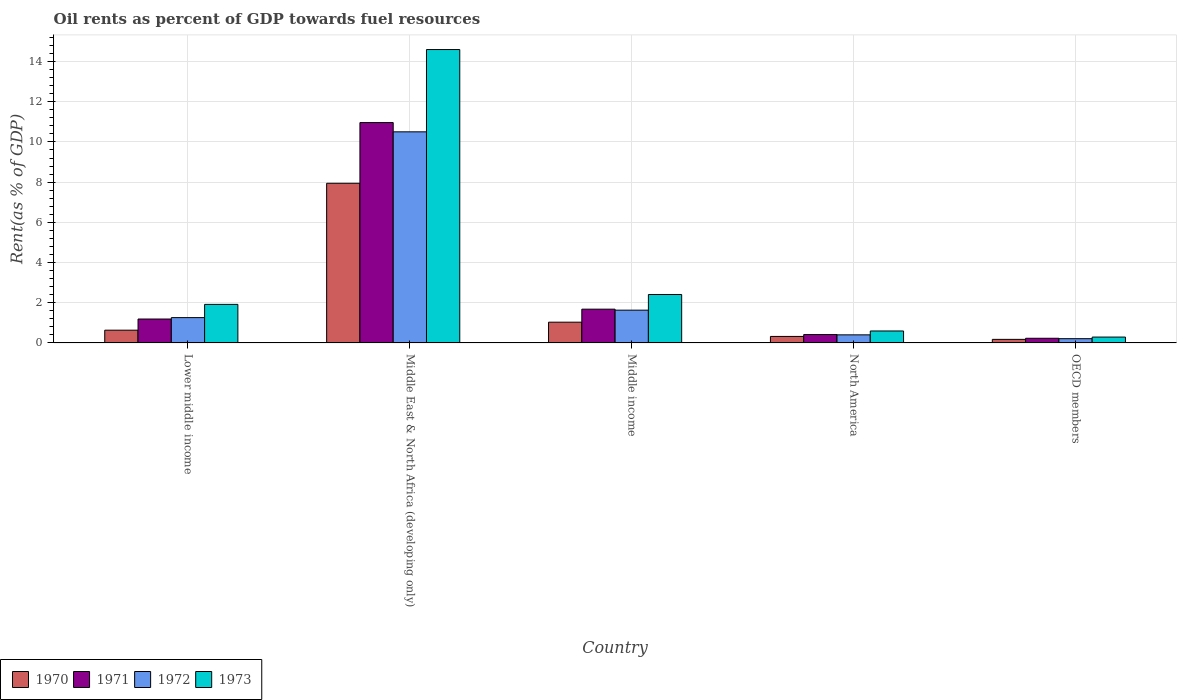Are the number of bars per tick equal to the number of legend labels?
Keep it short and to the point. Yes. What is the oil rent in 1973 in Middle income?
Your response must be concise. 2.41. Across all countries, what is the maximum oil rent in 1970?
Provide a short and direct response. 7.94. Across all countries, what is the minimum oil rent in 1970?
Give a very brief answer. 0.18. In which country was the oil rent in 1972 maximum?
Provide a short and direct response. Middle East & North Africa (developing only). What is the total oil rent in 1970 in the graph?
Ensure brevity in your answer.  10.11. What is the difference between the oil rent in 1971 in Middle East & North Africa (developing only) and that in North America?
Your answer should be very brief. 10.55. What is the difference between the oil rent in 1972 in Middle East & North Africa (developing only) and the oil rent in 1973 in Lower middle income?
Make the answer very short. 8.58. What is the average oil rent in 1972 per country?
Provide a short and direct response. 2.8. What is the difference between the oil rent of/in 1972 and oil rent of/in 1971 in Middle income?
Provide a short and direct response. -0.05. What is the ratio of the oil rent in 1971 in Middle income to that in North America?
Your response must be concise. 4.03. Is the difference between the oil rent in 1972 in Lower middle income and Middle East & North Africa (developing only) greater than the difference between the oil rent in 1971 in Lower middle income and Middle East & North Africa (developing only)?
Your answer should be compact. Yes. What is the difference between the highest and the second highest oil rent in 1973?
Keep it short and to the point. -0.49. What is the difference between the highest and the lowest oil rent in 1973?
Provide a succinct answer. 14.3. In how many countries, is the oil rent in 1972 greater than the average oil rent in 1972 taken over all countries?
Make the answer very short. 1. Is the sum of the oil rent in 1971 in Middle East & North Africa (developing only) and OECD members greater than the maximum oil rent in 1972 across all countries?
Your answer should be compact. Yes. Is it the case that in every country, the sum of the oil rent in 1971 and oil rent in 1973 is greater than the sum of oil rent in 1970 and oil rent in 1972?
Keep it short and to the point. No. What does the 4th bar from the left in OECD members represents?
Offer a very short reply. 1973. Is it the case that in every country, the sum of the oil rent in 1972 and oil rent in 1970 is greater than the oil rent in 1973?
Keep it short and to the point. No. Are the values on the major ticks of Y-axis written in scientific E-notation?
Provide a succinct answer. No. Does the graph contain any zero values?
Your answer should be very brief. No. How many legend labels are there?
Provide a short and direct response. 4. How are the legend labels stacked?
Offer a very short reply. Horizontal. What is the title of the graph?
Provide a short and direct response. Oil rents as percent of GDP towards fuel resources. Does "1991" appear as one of the legend labels in the graph?
Provide a succinct answer. No. What is the label or title of the Y-axis?
Ensure brevity in your answer.  Rent(as % of GDP). What is the Rent(as % of GDP) in 1970 in Lower middle income?
Provide a succinct answer. 0.63. What is the Rent(as % of GDP) of 1971 in Lower middle income?
Offer a terse response. 1.19. What is the Rent(as % of GDP) of 1972 in Lower middle income?
Your response must be concise. 1.26. What is the Rent(as % of GDP) of 1973 in Lower middle income?
Provide a short and direct response. 1.92. What is the Rent(as % of GDP) in 1970 in Middle East & North Africa (developing only)?
Keep it short and to the point. 7.94. What is the Rent(as % of GDP) in 1971 in Middle East & North Africa (developing only)?
Provide a short and direct response. 10.96. What is the Rent(as % of GDP) of 1972 in Middle East & North Africa (developing only)?
Your response must be concise. 10.5. What is the Rent(as % of GDP) of 1973 in Middle East & North Africa (developing only)?
Make the answer very short. 14.6. What is the Rent(as % of GDP) in 1970 in Middle income?
Provide a short and direct response. 1.03. What is the Rent(as % of GDP) in 1971 in Middle income?
Provide a succinct answer. 1.68. What is the Rent(as % of GDP) of 1972 in Middle income?
Provide a succinct answer. 1.63. What is the Rent(as % of GDP) in 1973 in Middle income?
Make the answer very short. 2.41. What is the Rent(as % of GDP) of 1970 in North America?
Offer a terse response. 0.32. What is the Rent(as % of GDP) in 1971 in North America?
Your answer should be compact. 0.42. What is the Rent(as % of GDP) in 1972 in North America?
Ensure brevity in your answer.  0.4. What is the Rent(as % of GDP) in 1973 in North America?
Your response must be concise. 0.6. What is the Rent(as % of GDP) in 1970 in OECD members?
Your answer should be compact. 0.18. What is the Rent(as % of GDP) of 1971 in OECD members?
Make the answer very short. 0.23. What is the Rent(as % of GDP) of 1972 in OECD members?
Keep it short and to the point. 0.21. What is the Rent(as % of GDP) of 1973 in OECD members?
Keep it short and to the point. 0.29. Across all countries, what is the maximum Rent(as % of GDP) in 1970?
Provide a short and direct response. 7.94. Across all countries, what is the maximum Rent(as % of GDP) of 1971?
Your response must be concise. 10.96. Across all countries, what is the maximum Rent(as % of GDP) in 1972?
Your response must be concise. 10.5. Across all countries, what is the maximum Rent(as % of GDP) in 1973?
Your answer should be compact. 14.6. Across all countries, what is the minimum Rent(as % of GDP) of 1970?
Provide a succinct answer. 0.18. Across all countries, what is the minimum Rent(as % of GDP) of 1971?
Your answer should be very brief. 0.23. Across all countries, what is the minimum Rent(as % of GDP) of 1972?
Offer a very short reply. 0.21. Across all countries, what is the minimum Rent(as % of GDP) of 1973?
Offer a terse response. 0.29. What is the total Rent(as % of GDP) in 1970 in the graph?
Your answer should be compact. 10.11. What is the total Rent(as % of GDP) in 1971 in the graph?
Provide a short and direct response. 14.48. What is the total Rent(as % of GDP) of 1972 in the graph?
Offer a terse response. 14.01. What is the total Rent(as % of GDP) in 1973 in the graph?
Your answer should be very brief. 19.81. What is the difference between the Rent(as % of GDP) of 1970 in Lower middle income and that in Middle East & North Africa (developing only)?
Your answer should be compact. -7.31. What is the difference between the Rent(as % of GDP) of 1971 in Lower middle income and that in Middle East & North Africa (developing only)?
Make the answer very short. -9.77. What is the difference between the Rent(as % of GDP) in 1972 in Lower middle income and that in Middle East & North Africa (developing only)?
Provide a short and direct response. -9.24. What is the difference between the Rent(as % of GDP) of 1973 in Lower middle income and that in Middle East & North Africa (developing only)?
Offer a very short reply. -12.68. What is the difference between the Rent(as % of GDP) in 1970 in Lower middle income and that in Middle income?
Keep it short and to the point. -0.4. What is the difference between the Rent(as % of GDP) of 1971 in Lower middle income and that in Middle income?
Provide a succinct answer. -0.49. What is the difference between the Rent(as % of GDP) of 1972 in Lower middle income and that in Middle income?
Your answer should be compact. -0.37. What is the difference between the Rent(as % of GDP) of 1973 in Lower middle income and that in Middle income?
Keep it short and to the point. -0.49. What is the difference between the Rent(as % of GDP) in 1970 in Lower middle income and that in North America?
Your answer should be compact. 0.31. What is the difference between the Rent(as % of GDP) in 1971 in Lower middle income and that in North America?
Offer a terse response. 0.77. What is the difference between the Rent(as % of GDP) of 1972 in Lower middle income and that in North America?
Keep it short and to the point. 0.86. What is the difference between the Rent(as % of GDP) in 1973 in Lower middle income and that in North America?
Make the answer very short. 1.32. What is the difference between the Rent(as % of GDP) in 1970 in Lower middle income and that in OECD members?
Your answer should be compact. 0.46. What is the difference between the Rent(as % of GDP) of 1971 in Lower middle income and that in OECD members?
Your answer should be compact. 0.96. What is the difference between the Rent(as % of GDP) in 1972 in Lower middle income and that in OECD members?
Your answer should be very brief. 1.05. What is the difference between the Rent(as % of GDP) of 1973 in Lower middle income and that in OECD members?
Your answer should be compact. 1.63. What is the difference between the Rent(as % of GDP) of 1970 in Middle East & North Africa (developing only) and that in Middle income?
Ensure brevity in your answer.  6.91. What is the difference between the Rent(as % of GDP) in 1971 in Middle East & North Africa (developing only) and that in Middle income?
Your answer should be very brief. 9.28. What is the difference between the Rent(as % of GDP) of 1972 in Middle East & North Africa (developing only) and that in Middle income?
Offer a very short reply. 8.87. What is the difference between the Rent(as % of GDP) in 1973 in Middle East & North Africa (developing only) and that in Middle income?
Provide a succinct answer. 12.19. What is the difference between the Rent(as % of GDP) of 1970 in Middle East & North Africa (developing only) and that in North America?
Ensure brevity in your answer.  7.62. What is the difference between the Rent(as % of GDP) in 1971 in Middle East & North Africa (developing only) and that in North America?
Keep it short and to the point. 10.55. What is the difference between the Rent(as % of GDP) of 1972 in Middle East & North Africa (developing only) and that in North America?
Offer a terse response. 10.1. What is the difference between the Rent(as % of GDP) of 1973 in Middle East & North Africa (developing only) and that in North America?
Give a very brief answer. 14. What is the difference between the Rent(as % of GDP) in 1970 in Middle East & North Africa (developing only) and that in OECD members?
Keep it short and to the point. 7.77. What is the difference between the Rent(as % of GDP) of 1971 in Middle East & North Africa (developing only) and that in OECD members?
Offer a terse response. 10.73. What is the difference between the Rent(as % of GDP) of 1972 in Middle East & North Africa (developing only) and that in OECD members?
Make the answer very short. 10.29. What is the difference between the Rent(as % of GDP) of 1973 in Middle East & North Africa (developing only) and that in OECD members?
Your answer should be compact. 14.3. What is the difference between the Rent(as % of GDP) in 1970 in Middle income and that in North America?
Give a very brief answer. 0.71. What is the difference between the Rent(as % of GDP) of 1971 in Middle income and that in North America?
Offer a terse response. 1.26. What is the difference between the Rent(as % of GDP) of 1972 in Middle income and that in North America?
Provide a succinct answer. 1.23. What is the difference between the Rent(as % of GDP) of 1973 in Middle income and that in North America?
Your answer should be compact. 1.81. What is the difference between the Rent(as % of GDP) in 1970 in Middle income and that in OECD members?
Your answer should be compact. 0.85. What is the difference between the Rent(as % of GDP) in 1971 in Middle income and that in OECD members?
Keep it short and to the point. 1.45. What is the difference between the Rent(as % of GDP) of 1972 in Middle income and that in OECD members?
Your answer should be compact. 1.42. What is the difference between the Rent(as % of GDP) of 1973 in Middle income and that in OECD members?
Ensure brevity in your answer.  2.12. What is the difference between the Rent(as % of GDP) in 1970 in North America and that in OECD members?
Ensure brevity in your answer.  0.15. What is the difference between the Rent(as % of GDP) in 1971 in North America and that in OECD members?
Ensure brevity in your answer.  0.18. What is the difference between the Rent(as % of GDP) of 1972 in North America and that in OECD members?
Your response must be concise. 0.19. What is the difference between the Rent(as % of GDP) of 1973 in North America and that in OECD members?
Your response must be concise. 0.3. What is the difference between the Rent(as % of GDP) in 1970 in Lower middle income and the Rent(as % of GDP) in 1971 in Middle East & North Africa (developing only)?
Ensure brevity in your answer.  -10.33. What is the difference between the Rent(as % of GDP) of 1970 in Lower middle income and the Rent(as % of GDP) of 1972 in Middle East & North Africa (developing only)?
Make the answer very short. -9.87. What is the difference between the Rent(as % of GDP) in 1970 in Lower middle income and the Rent(as % of GDP) in 1973 in Middle East & North Africa (developing only)?
Your answer should be compact. -13.96. What is the difference between the Rent(as % of GDP) of 1971 in Lower middle income and the Rent(as % of GDP) of 1972 in Middle East & North Africa (developing only)?
Offer a terse response. -9.31. What is the difference between the Rent(as % of GDP) in 1971 in Lower middle income and the Rent(as % of GDP) in 1973 in Middle East & North Africa (developing only)?
Offer a very short reply. -13.41. What is the difference between the Rent(as % of GDP) in 1972 in Lower middle income and the Rent(as % of GDP) in 1973 in Middle East & North Africa (developing only)?
Keep it short and to the point. -13.34. What is the difference between the Rent(as % of GDP) in 1970 in Lower middle income and the Rent(as % of GDP) in 1971 in Middle income?
Your answer should be very brief. -1.05. What is the difference between the Rent(as % of GDP) of 1970 in Lower middle income and the Rent(as % of GDP) of 1972 in Middle income?
Offer a terse response. -1. What is the difference between the Rent(as % of GDP) in 1970 in Lower middle income and the Rent(as % of GDP) in 1973 in Middle income?
Provide a short and direct response. -1.77. What is the difference between the Rent(as % of GDP) of 1971 in Lower middle income and the Rent(as % of GDP) of 1972 in Middle income?
Your answer should be compact. -0.44. What is the difference between the Rent(as % of GDP) of 1971 in Lower middle income and the Rent(as % of GDP) of 1973 in Middle income?
Give a very brief answer. -1.22. What is the difference between the Rent(as % of GDP) of 1972 in Lower middle income and the Rent(as % of GDP) of 1973 in Middle income?
Your answer should be very brief. -1.15. What is the difference between the Rent(as % of GDP) in 1970 in Lower middle income and the Rent(as % of GDP) in 1971 in North America?
Provide a succinct answer. 0.22. What is the difference between the Rent(as % of GDP) of 1970 in Lower middle income and the Rent(as % of GDP) of 1972 in North America?
Give a very brief answer. 0.23. What is the difference between the Rent(as % of GDP) in 1970 in Lower middle income and the Rent(as % of GDP) in 1973 in North America?
Keep it short and to the point. 0.04. What is the difference between the Rent(as % of GDP) in 1971 in Lower middle income and the Rent(as % of GDP) in 1972 in North America?
Your answer should be compact. 0.79. What is the difference between the Rent(as % of GDP) of 1971 in Lower middle income and the Rent(as % of GDP) of 1973 in North America?
Your answer should be very brief. 0.6. What is the difference between the Rent(as % of GDP) of 1972 in Lower middle income and the Rent(as % of GDP) of 1973 in North America?
Your answer should be very brief. 0.66. What is the difference between the Rent(as % of GDP) of 1970 in Lower middle income and the Rent(as % of GDP) of 1971 in OECD members?
Your answer should be very brief. 0.4. What is the difference between the Rent(as % of GDP) in 1970 in Lower middle income and the Rent(as % of GDP) in 1972 in OECD members?
Your response must be concise. 0.42. What is the difference between the Rent(as % of GDP) in 1970 in Lower middle income and the Rent(as % of GDP) in 1973 in OECD members?
Make the answer very short. 0.34. What is the difference between the Rent(as % of GDP) of 1971 in Lower middle income and the Rent(as % of GDP) of 1972 in OECD members?
Provide a short and direct response. 0.98. What is the difference between the Rent(as % of GDP) of 1971 in Lower middle income and the Rent(as % of GDP) of 1973 in OECD members?
Your response must be concise. 0.9. What is the difference between the Rent(as % of GDP) of 1972 in Lower middle income and the Rent(as % of GDP) of 1973 in OECD members?
Your response must be concise. 0.97. What is the difference between the Rent(as % of GDP) in 1970 in Middle East & North Africa (developing only) and the Rent(as % of GDP) in 1971 in Middle income?
Offer a very short reply. 6.26. What is the difference between the Rent(as % of GDP) in 1970 in Middle East & North Africa (developing only) and the Rent(as % of GDP) in 1972 in Middle income?
Offer a very short reply. 6.31. What is the difference between the Rent(as % of GDP) in 1970 in Middle East & North Africa (developing only) and the Rent(as % of GDP) in 1973 in Middle income?
Offer a very short reply. 5.53. What is the difference between the Rent(as % of GDP) of 1971 in Middle East & North Africa (developing only) and the Rent(as % of GDP) of 1972 in Middle income?
Give a very brief answer. 9.33. What is the difference between the Rent(as % of GDP) in 1971 in Middle East & North Africa (developing only) and the Rent(as % of GDP) in 1973 in Middle income?
Provide a short and direct response. 8.55. What is the difference between the Rent(as % of GDP) of 1972 in Middle East & North Africa (developing only) and the Rent(as % of GDP) of 1973 in Middle income?
Your answer should be very brief. 8.09. What is the difference between the Rent(as % of GDP) of 1970 in Middle East & North Africa (developing only) and the Rent(as % of GDP) of 1971 in North America?
Ensure brevity in your answer.  7.53. What is the difference between the Rent(as % of GDP) in 1970 in Middle East & North Africa (developing only) and the Rent(as % of GDP) in 1972 in North America?
Your response must be concise. 7.54. What is the difference between the Rent(as % of GDP) of 1970 in Middle East & North Africa (developing only) and the Rent(as % of GDP) of 1973 in North America?
Provide a succinct answer. 7.35. What is the difference between the Rent(as % of GDP) in 1971 in Middle East & North Africa (developing only) and the Rent(as % of GDP) in 1972 in North America?
Make the answer very short. 10.56. What is the difference between the Rent(as % of GDP) in 1971 in Middle East & North Africa (developing only) and the Rent(as % of GDP) in 1973 in North America?
Offer a very short reply. 10.37. What is the difference between the Rent(as % of GDP) in 1972 in Middle East & North Africa (developing only) and the Rent(as % of GDP) in 1973 in North America?
Ensure brevity in your answer.  9.91. What is the difference between the Rent(as % of GDP) of 1970 in Middle East & North Africa (developing only) and the Rent(as % of GDP) of 1971 in OECD members?
Make the answer very short. 7.71. What is the difference between the Rent(as % of GDP) of 1970 in Middle East & North Africa (developing only) and the Rent(as % of GDP) of 1972 in OECD members?
Your answer should be very brief. 7.73. What is the difference between the Rent(as % of GDP) in 1970 in Middle East & North Africa (developing only) and the Rent(as % of GDP) in 1973 in OECD members?
Provide a short and direct response. 7.65. What is the difference between the Rent(as % of GDP) in 1971 in Middle East & North Africa (developing only) and the Rent(as % of GDP) in 1972 in OECD members?
Make the answer very short. 10.75. What is the difference between the Rent(as % of GDP) in 1971 in Middle East & North Africa (developing only) and the Rent(as % of GDP) in 1973 in OECD members?
Provide a short and direct response. 10.67. What is the difference between the Rent(as % of GDP) in 1972 in Middle East & North Africa (developing only) and the Rent(as % of GDP) in 1973 in OECD members?
Offer a very short reply. 10.21. What is the difference between the Rent(as % of GDP) in 1970 in Middle income and the Rent(as % of GDP) in 1971 in North America?
Give a very brief answer. 0.61. What is the difference between the Rent(as % of GDP) of 1970 in Middle income and the Rent(as % of GDP) of 1972 in North America?
Offer a very short reply. 0.63. What is the difference between the Rent(as % of GDP) in 1970 in Middle income and the Rent(as % of GDP) in 1973 in North America?
Ensure brevity in your answer.  0.44. What is the difference between the Rent(as % of GDP) of 1971 in Middle income and the Rent(as % of GDP) of 1972 in North America?
Ensure brevity in your answer.  1.28. What is the difference between the Rent(as % of GDP) in 1971 in Middle income and the Rent(as % of GDP) in 1973 in North America?
Offer a terse response. 1.09. What is the difference between the Rent(as % of GDP) in 1972 in Middle income and the Rent(as % of GDP) in 1973 in North America?
Provide a succinct answer. 1.04. What is the difference between the Rent(as % of GDP) in 1970 in Middle income and the Rent(as % of GDP) in 1971 in OECD members?
Make the answer very short. 0.8. What is the difference between the Rent(as % of GDP) in 1970 in Middle income and the Rent(as % of GDP) in 1972 in OECD members?
Provide a succinct answer. 0.82. What is the difference between the Rent(as % of GDP) in 1970 in Middle income and the Rent(as % of GDP) in 1973 in OECD members?
Offer a terse response. 0.74. What is the difference between the Rent(as % of GDP) of 1971 in Middle income and the Rent(as % of GDP) of 1972 in OECD members?
Your response must be concise. 1.47. What is the difference between the Rent(as % of GDP) of 1971 in Middle income and the Rent(as % of GDP) of 1973 in OECD members?
Make the answer very short. 1.39. What is the difference between the Rent(as % of GDP) of 1972 in Middle income and the Rent(as % of GDP) of 1973 in OECD members?
Ensure brevity in your answer.  1.34. What is the difference between the Rent(as % of GDP) in 1970 in North America and the Rent(as % of GDP) in 1971 in OECD members?
Your answer should be very brief. 0.09. What is the difference between the Rent(as % of GDP) in 1970 in North America and the Rent(as % of GDP) in 1972 in OECD members?
Your response must be concise. 0.11. What is the difference between the Rent(as % of GDP) of 1970 in North America and the Rent(as % of GDP) of 1973 in OECD members?
Ensure brevity in your answer.  0.03. What is the difference between the Rent(as % of GDP) in 1971 in North America and the Rent(as % of GDP) in 1972 in OECD members?
Give a very brief answer. 0.21. What is the difference between the Rent(as % of GDP) of 1971 in North America and the Rent(as % of GDP) of 1973 in OECD members?
Keep it short and to the point. 0.13. What is the difference between the Rent(as % of GDP) in 1972 in North America and the Rent(as % of GDP) in 1973 in OECD members?
Offer a terse response. 0.11. What is the average Rent(as % of GDP) of 1970 per country?
Keep it short and to the point. 2.02. What is the average Rent(as % of GDP) of 1971 per country?
Give a very brief answer. 2.9. What is the average Rent(as % of GDP) of 1972 per country?
Ensure brevity in your answer.  2.8. What is the average Rent(as % of GDP) in 1973 per country?
Offer a terse response. 3.96. What is the difference between the Rent(as % of GDP) in 1970 and Rent(as % of GDP) in 1971 in Lower middle income?
Ensure brevity in your answer.  -0.56. What is the difference between the Rent(as % of GDP) of 1970 and Rent(as % of GDP) of 1972 in Lower middle income?
Ensure brevity in your answer.  -0.62. What is the difference between the Rent(as % of GDP) of 1970 and Rent(as % of GDP) of 1973 in Lower middle income?
Offer a terse response. -1.28. What is the difference between the Rent(as % of GDP) of 1971 and Rent(as % of GDP) of 1972 in Lower middle income?
Provide a short and direct response. -0.07. What is the difference between the Rent(as % of GDP) of 1971 and Rent(as % of GDP) of 1973 in Lower middle income?
Offer a very short reply. -0.73. What is the difference between the Rent(as % of GDP) in 1972 and Rent(as % of GDP) in 1973 in Lower middle income?
Your response must be concise. -0.66. What is the difference between the Rent(as % of GDP) in 1970 and Rent(as % of GDP) in 1971 in Middle East & North Africa (developing only)?
Provide a succinct answer. -3.02. What is the difference between the Rent(as % of GDP) of 1970 and Rent(as % of GDP) of 1972 in Middle East & North Africa (developing only)?
Keep it short and to the point. -2.56. What is the difference between the Rent(as % of GDP) of 1970 and Rent(as % of GDP) of 1973 in Middle East & North Africa (developing only)?
Keep it short and to the point. -6.65. What is the difference between the Rent(as % of GDP) of 1971 and Rent(as % of GDP) of 1972 in Middle East & North Africa (developing only)?
Make the answer very short. 0.46. What is the difference between the Rent(as % of GDP) of 1971 and Rent(as % of GDP) of 1973 in Middle East & North Africa (developing only)?
Offer a terse response. -3.63. What is the difference between the Rent(as % of GDP) in 1972 and Rent(as % of GDP) in 1973 in Middle East & North Africa (developing only)?
Offer a very short reply. -4.09. What is the difference between the Rent(as % of GDP) in 1970 and Rent(as % of GDP) in 1971 in Middle income?
Ensure brevity in your answer.  -0.65. What is the difference between the Rent(as % of GDP) of 1970 and Rent(as % of GDP) of 1972 in Middle income?
Provide a succinct answer. -0.6. What is the difference between the Rent(as % of GDP) of 1970 and Rent(as % of GDP) of 1973 in Middle income?
Ensure brevity in your answer.  -1.38. What is the difference between the Rent(as % of GDP) of 1971 and Rent(as % of GDP) of 1972 in Middle income?
Give a very brief answer. 0.05. What is the difference between the Rent(as % of GDP) of 1971 and Rent(as % of GDP) of 1973 in Middle income?
Your response must be concise. -0.73. What is the difference between the Rent(as % of GDP) of 1972 and Rent(as % of GDP) of 1973 in Middle income?
Ensure brevity in your answer.  -0.78. What is the difference between the Rent(as % of GDP) in 1970 and Rent(as % of GDP) in 1971 in North America?
Keep it short and to the point. -0.09. What is the difference between the Rent(as % of GDP) of 1970 and Rent(as % of GDP) of 1972 in North America?
Make the answer very short. -0.08. What is the difference between the Rent(as % of GDP) of 1970 and Rent(as % of GDP) of 1973 in North America?
Your response must be concise. -0.27. What is the difference between the Rent(as % of GDP) in 1971 and Rent(as % of GDP) in 1972 in North America?
Give a very brief answer. 0.02. What is the difference between the Rent(as % of GDP) of 1971 and Rent(as % of GDP) of 1973 in North America?
Offer a terse response. -0.18. What is the difference between the Rent(as % of GDP) in 1972 and Rent(as % of GDP) in 1973 in North America?
Your answer should be very brief. -0.19. What is the difference between the Rent(as % of GDP) of 1970 and Rent(as % of GDP) of 1971 in OECD members?
Offer a very short reply. -0.05. What is the difference between the Rent(as % of GDP) of 1970 and Rent(as % of GDP) of 1972 in OECD members?
Offer a terse response. -0.03. What is the difference between the Rent(as % of GDP) of 1970 and Rent(as % of GDP) of 1973 in OECD members?
Your response must be concise. -0.11. What is the difference between the Rent(as % of GDP) of 1971 and Rent(as % of GDP) of 1972 in OECD members?
Provide a succinct answer. 0.02. What is the difference between the Rent(as % of GDP) of 1971 and Rent(as % of GDP) of 1973 in OECD members?
Offer a very short reply. -0.06. What is the difference between the Rent(as % of GDP) of 1972 and Rent(as % of GDP) of 1973 in OECD members?
Provide a succinct answer. -0.08. What is the ratio of the Rent(as % of GDP) of 1970 in Lower middle income to that in Middle East & North Africa (developing only)?
Keep it short and to the point. 0.08. What is the ratio of the Rent(as % of GDP) of 1971 in Lower middle income to that in Middle East & North Africa (developing only)?
Offer a terse response. 0.11. What is the ratio of the Rent(as % of GDP) in 1972 in Lower middle income to that in Middle East & North Africa (developing only)?
Offer a very short reply. 0.12. What is the ratio of the Rent(as % of GDP) in 1973 in Lower middle income to that in Middle East & North Africa (developing only)?
Make the answer very short. 0.13. What is the ratio of the Rent(as % of GDP) of 1970 in Lower middle income to that in Middle income?
Provide a short and direct response. 0.61. What is the ratio of the Rent(as % of GDP) in 1971 in Lower middle income to that in Middle income?
Make the answer very short. 0.71. What is the ratio of the Rent(as % of GDP) in 1972 in Lower middle income to that in Middle income?
Your answer should be compact. 0.77. What is the ratio of the Rent(as % of GDP) in 1973 in Lower middle income to that in Middle income?
Ensure brevity in your answer.  0.8. What is the ratio of the Rent(as % of GDP) of 1970 in Lower middle income to that in North America?
Your answer should be compact. 1.96. What is the ratio of the Rent(as % of GDP) of 1971 in Lower middle income to that in North America?
Offer a terse response. 2.85. What is the ratio of the Rent(as % of GDP) of 1972 in Lower middle income to that in North America?
Make the answer very short. 3.13. What is the ratio of the Rent(as % of GDP) of 1973 in Lower middle income to that in North America?
Keep it short and to the point. 3.22. What is the ratio of the Rent(as % of GDP) in 1970 in Lower middle income to that in OECD members?
Your response must be concise. 3.57. What is the ratio of the Rent(as % of GDP) of 1971 in Lower middle income to that in OECD members?
Offer a terse response. 5.12. What is the ratio of the Rent(as % of GDP) in 1972 in Lower middle income to that in OECD members?
Ensure brevity in your answer.  5.94. What is the ratio of the Rent(as % of GDP) in 1973 in Lower middle income to that in OECD members?
Provide a succinct answer. 6.58. What is the ratio of the Rent(as % of GDP) of 1970 in Middle East & North Africa (developing only) to that in Middle income?
Offer a very short reply. 7.69. What is the ratio of the Rent(as % of GDP) in 1971 in Middle East & North Africa (developing only) to that in Middle income?
Offer a terse response. 6.52. What is the ratio of the Rent(as % of GDP) of 1972 in Middle East & North Africa (developing only) to that in Middle income?
Offer a terse response. 6.44. What is the ratio of the Rent(as % of GDP) in 1973 in Middle East & North Africa (developing only) to that in Middle income?
Your response must be concise. 6.06. What is the ratio of the Rent(as % of GDP) of 1970 in Middle East & North Africa (developing only) to that in North America?
Provide a succinct answer. 24.54. What is the ratio of the Rent(as % of GDP) in 1971 in Middle East & North Africa (developing only) to that in North America?
Offer a very short reply. 26.26. What is the ratio of the Rent(as % of GDP) of 1972 in Middle East & North Africa (developing only) to that in North America?
Your answer should be compact. 26.11. What is the ratio of the Rent(as % of GDP) in 1973 in Middle East & North Africa (developing only) to that in North America?
Give a very brief answer. 24.53. What is the ratio of the Rent(as % of GDP) of 1970 in Middle East & North Africa (developing only) to that in OECD members?
Offer a very short reply. 44.68. What is the ratio of the Rent(as % of GDP) in 1971 in Middle East & North Africa (developing only) to that in OECD members?
Make the answer very short. 47.15. What is the ratio of the Rent(as % of GDP) in 1972 in Middle East & North Africa (developing only) to that in OECD members?
Your answer should be very brief. 49.49. What is the ratio of the Rent(as % of GDP) in 1973 in Middle East & North Africa (developing only) to that in OECD members?
Ensure brevity in your answer.  50.04. What is the ratio of the Rent(as % of GDP) of 1970 in Middle income to that in North America?
Make the answer very short. 3.19. What is the ratio of the Rent(as % of GDP) in 1971 in Middle income to that in North America?
Make the answer very short. 4.03. What is the ratio of the Rent(as % of GDP) of 1972 in Middle income to that in North America?
Your answer should be compact. 4.05. What is the ratio of the Rent(as % of GDP) in 1973 in Middle income to that in North America?
Give a very brief answer. 4.05. What is the ratio of the Rent(as % of GDP) of 1970 in Middle income to that in OECD members?
Offer a terse response. 5.81. What is the ratio of the Rent(as % of GDP) in 1971 in Middle income to that in OECD members?
Ensure brevity in your answer.  7.23. What is the ratio of the Rent(as % of GDP) in 1972 in Middle income to that in OECD members?
Make the answer very short. 7.68. What is the ratio of the Rent(as % of GDP) in 1973 in Middle income to that in OECD members?
Make the answer very short. 8.26. What is the ratio of the Rent(as % of GDP) in 1970 in North America to that in OECD members?
Your answer should be very brief. 1.82. What is the ratio of the Rent(as % of GDP) in 1971 in North America to that in OECD members?
Your answer should be compact. 1.8. What is the ratio of the Rent(as % of GDP) in 1972 in North America to that in OECD members?
Keep it short and to the point. 1.9. What is the ratio of the Rent(as % of GDP) of 1973 in North America to that in OECD members?
Offer a terse response. 2.04. What is the difference between the highest and the second highest Rent(as % of GDP) of 1970?
Your response must be concise. 6.91. What is the difference between the highest and the second highest Rent(as % of GDP) in 1971?
Provide a short and direct response. 9.28. What is the difference between the highest and the second highest Rent(as % of GDP) of 1972?
Keep it short and to the point. 8.87. What is the difference between the highest and the second highest Rent(as % of GDP) in 1973?
Your answer should be very brief. 12.19. What is the difference between the highest and the lowest Rent(as % of GDP) in 1970?
Provide a succinct answer. 7.77. What is the difference between the highest and the lowest Rent(as % of GDP) in 1971?
Your answer should be very brief. 10.73. What is the difference between the highest and the lowest Rent(as % of GDP) of 1972?
Make the answer very short. 10.29. What is the difference between the highest and the lowest Rent(as % of GDP) of 1973?
Give a very brief answer. 14.3. 